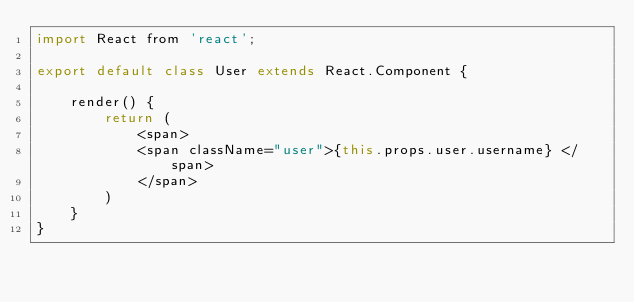<code> <loc_0><loc_0><loc_500><loc_500><_JavaScript_>import React from 'react';

export default class User extends React.Component {

    render() {
        return (
            <span>
            <span className="user">{this.props.user.username} </span>
            </span>
        )
    }
}
</code> 